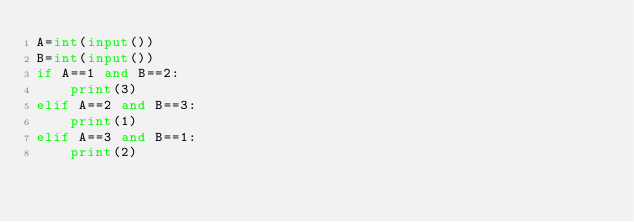<code> <loc_0><loc_0><loc_500><loc_500><_Python_>A=int(input())
B=int(input())
if A==1 and B==2:
    print(3)
elif A==2 and B==3:
    print(1)
elif A==3 and B==1:
    print(2)</code> 